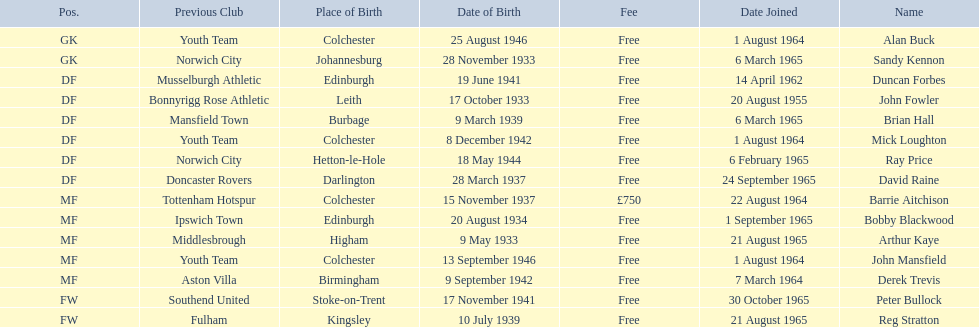When did alan buck join the colchester united f.c. in 1965-66? 1 August 1964. When did the last player to join? Peter Bullock. What date did the first player join? 20 August 1955. 